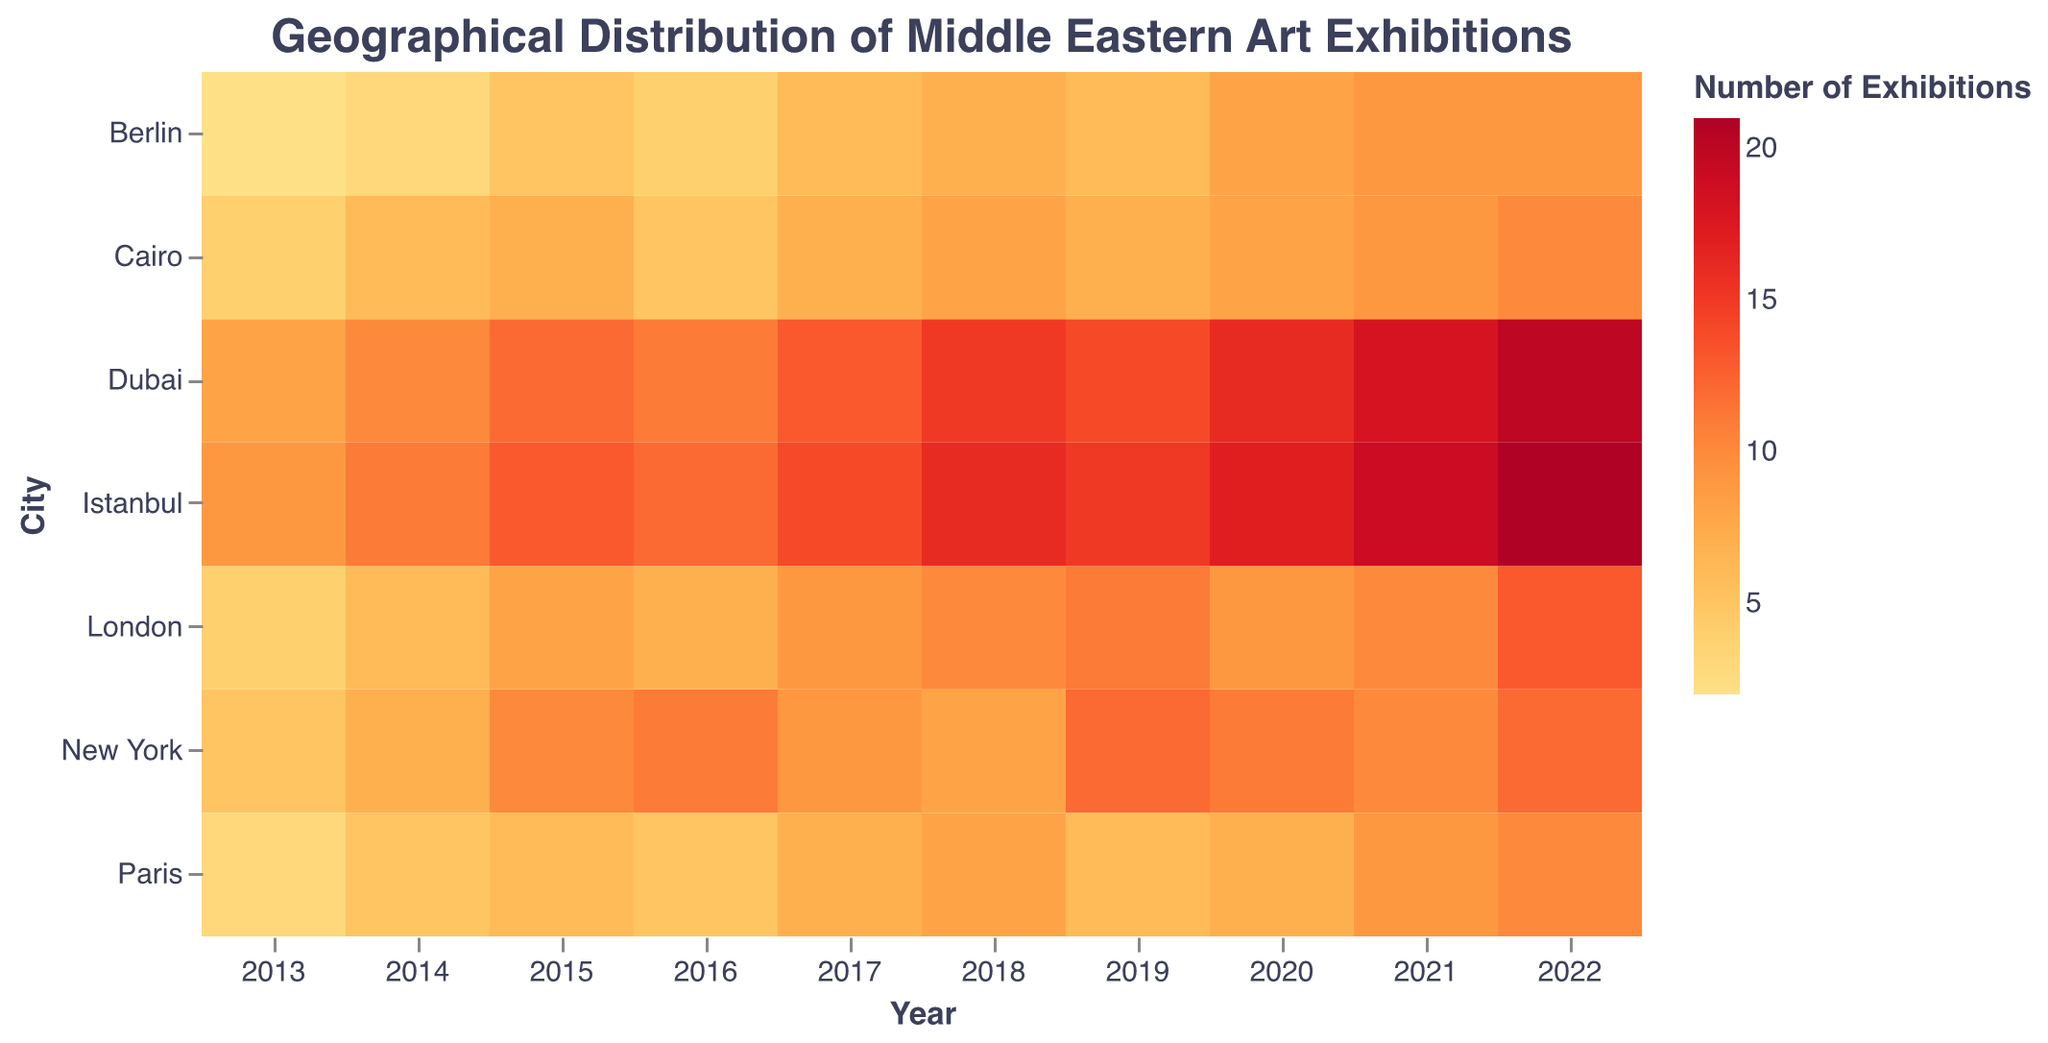Which city had the most Middle Eastern art exhibitions in 2022? To find the answer, look at the heatmap's color intensity for the year 2022. Dubai has the highest intensity indicating it had the most exhibitions.
Answer: Dubai Which year had the fewest Middle Eastern art exhibitions in Berlin? To answer this, look at the heatmap for Berlin and find the year with the least color intensity. The year 2013 has the least intensity, indicating the fewest exhibitions.
Answer: 2013 How did the number of exhibitions in New York change from 2016 to 2017? Compare the color intensities for New York between 2016 and 2017 on the heatmap. The intensity decreases slightly indicating a decrease from 11 to 9 exhibitions.
Answer: Decreased Which city showed the highest increase in the number of exhibitions from 2013 to 2022? For each city, compare the color intensity from 2013 to 2022. Istanbul shows a jump from a lighter intensity (9 exhibitions) in 2013 to a very high intensity (21 exhibitions) in 2022, indicating the highest increase.
Answer: Istanbul Which year had the overall highest number of exhibitions for the cities displayed? Look at the overall color intensity across all cities for each year. The year 2022 has the highest overall intensity, indicating the most exhibitions.
Answer: 2022 How does the number of exhibitions in Paris in 2021 compare to New York in the same year? Compare the color intensity for Paris and New York in 2021. Both cities have close intensities, but Paris has a slightly higher one, indicating 9 exhibitions compared to New York's 10.
Answer: Paris had 9, New York had 10 What is the trend in the number of exhibitions in Dubai from 2013 to 2022? Observe the color changes in Dubai from 2013 to 2022. The color intensity continuously increases, showing a positive trend in the number of exhibitions, from 8 in 2013 to 20 in 2022.
Answer: Increasing trend Which city had the most consistent number of exhibitions over the years? Look for a city with relatively uniform color intensity across years. Berlin shows a steady increase but remains more consistent compared to other cities.
Answer: Berlin How many years did Cairo have fewer than 7 exhibitions? Identify the color intensity representing fewer than 7 exhibitions and count those years for Cairo. The years are 2013, 2014, 2016, and 2019.
Answer: 4 years Which city had the highest difference in exhibitions between any two consecutive years? Identify the city with the most substantial color intensity change between any two years. New York shows fewer changes year on year, whereas Istanbul's change between 2021 and 2022 stands out. Istanbul had the highest difference from 19 to 21 exhibitions.
Answer: Istanbul 